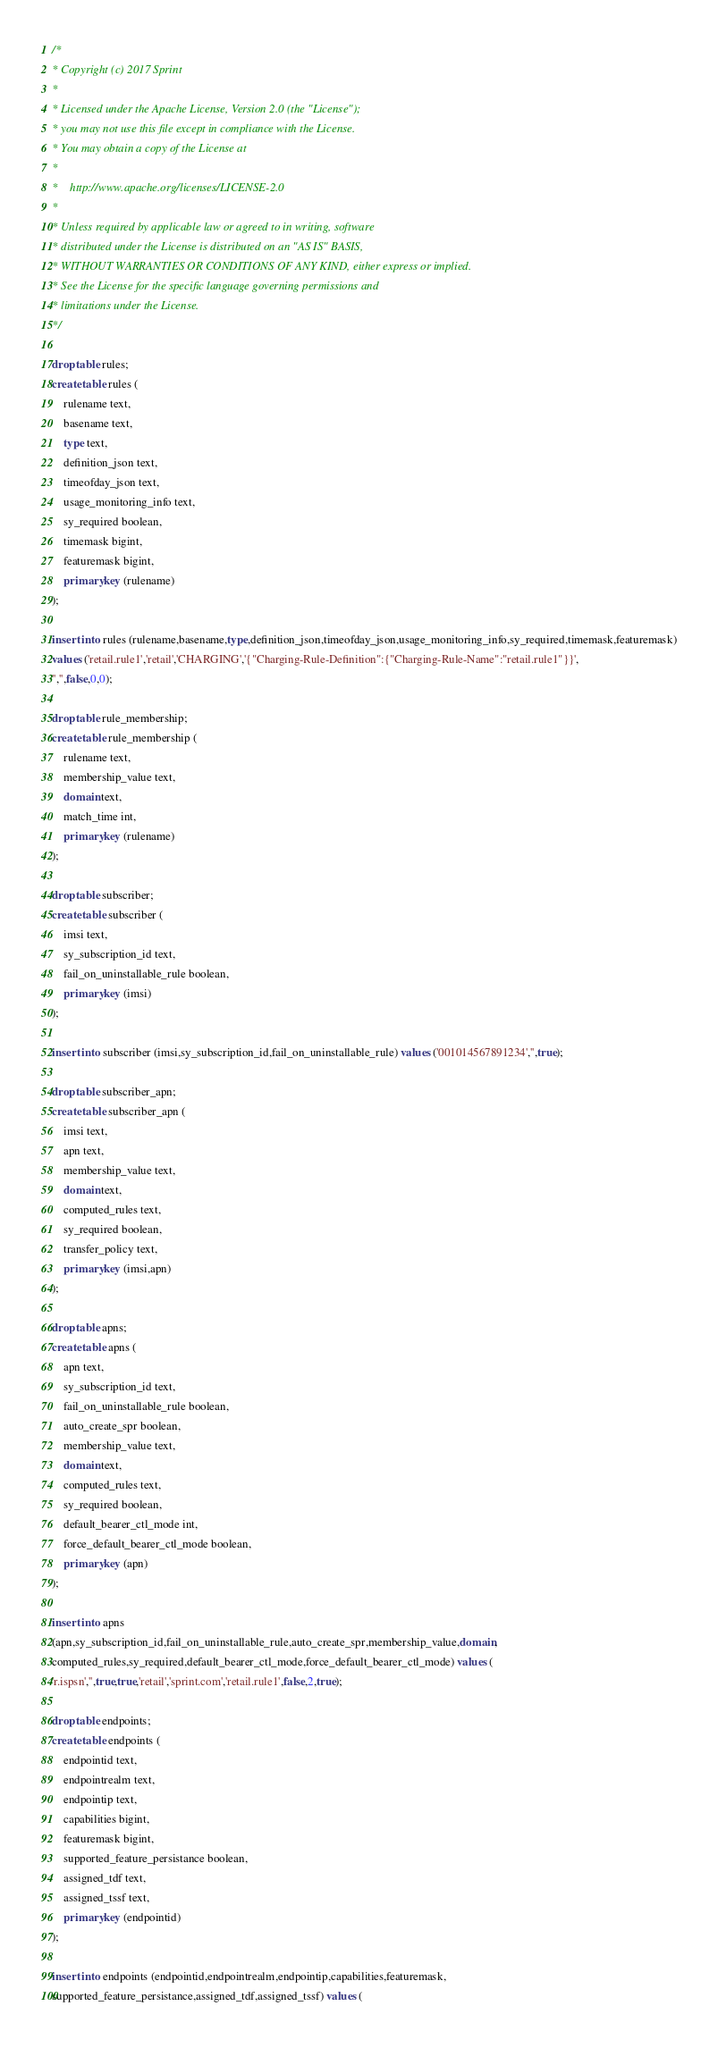<code> <loc_0><loc_0><loc_500><loc_500><_SQL_>/*
* Copyright (c) 2017 Sprint
*
* Licensed under the Apache License, Version 2.0 (the "License");
* you may not use this file except in compliance with the License.
* You may obtain a copy of the License at
*
*    http://www.apache.org/licenses/LICENSE-2.0
*
* Unless required by applicable law or agreed to in writing, software
* distributed under the License is distributed on an "AS IS" BASIS,
* WITHOUT WARRANTIES OR CONDITIONS OF ANY KIND, either express or implied.
* See the License for the specific language governing permissions and
* limitations under the License.
*/

drop table rules;
create table rules (
	rulename text,
	basename text,
	type text,
	definition_json text,
	timeofday_json text,
	usage_monitoring_info text,
	sy_required boolean,
	timemask bigint,
	featuremask bigint,
	primary key (rulename)
);

insert into rules (rulename,basename,type,definition_json,timeofday_json,usage_monitoring_info,sy_required,timemask,featuremask)
values ('retail.rule1','retail','CHARGING','{"Charging-Rule-Definition":{"Charging-Rule-Name":"retail.rule1"}}',
'','',false,0,0);

drop table rule_membership;
create table rule_membership (
	rulename text,
	membership_value text,
	domain text,
	match_time int,
	primary key (rulename)
);

drop table subscriber;
create table subscriber (
	imsi text,
	sy_subscription_id text,
	fail_on_uninstallable_rule boolean,
	primary key (imsi)
);

insert into subscriber (imsi,sy_subscription_id,fail_on_uninstallable_rule) values ('001014567891234','',true);

drop table subscriber_apn;
create table subscriber_apn (
	imsi text,
	apn text,
	membership_value text,
	domain text,
	computed_rules text,
	sy_required boolean,
	transfer_policy text,	
	primary key (imsi,apn)
);

drop table apns;
create table apns (
	apn text,
	sy_subscription_id text,
	fail_on_uninstallable_rule boolean,
	auto_create_spr boolean,
	membership_value text,
	domain text,
	computed_rules text,
	sy_required boolean,
	default_bearer_ctl_mode int,
	force_default_bearer_ctl_mode boolean,
	primary key (apn)
);

insert into apns
(apn,sy_subscription_id,fail_on_uninstallable_rule,auto_create_spr,membership_value,domain,
computed_rules,sy_required,default_bearer_ctl_mode,force_default_bearer_ctl_mode) values (
'r.ispsn','',true,true,'retail','sprint.com','retail.rule1',false,2,true);

drop table endpoints;
create table endpoints (
	endpointid text,
	endpointrealm text,
	endpointip text,
	capabilities bigint,
	featuremask bigint,
	supported_feature_persistance boolean,
	assigned_tdf text,
	assigned_tssf text,
	primary key (endpointid)
);

insert into endpoints (endpointid,endpointrealm,endpointip,capabilities,featuremask,
supported_feature_persistance,assigned_tdf,assigned_tssf) values (</code> 